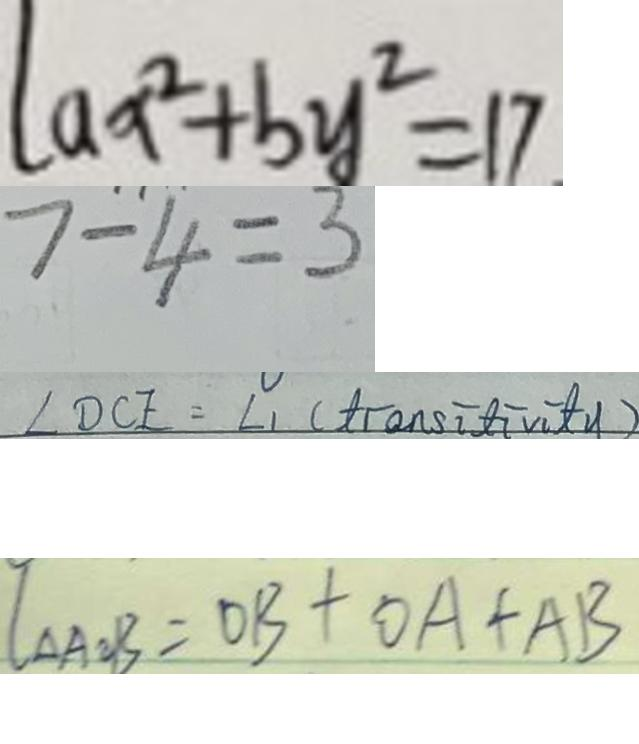Convert formula to latex. <formula><loc_0><loc_0><loc_500><loc_500>a x ^ { 2 } + b y ^ { 2 } = 1 7 
 7 - 4 = 3 
 \angle D C E = \angle 1 ( t t r a n s i t i v i y ) 
 I _ { \Delta A O B } = O B + O A + A B</formula> 